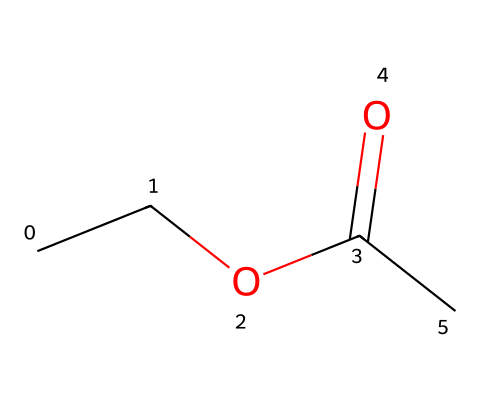What is the molecular formula of ethyl acetate? To determine the molecular formula, we need to count the number of each type of atom in the SMILES representation. The structure shows 4 carbon (C) atoms, 8 hydrogen (H) atoms, and 2 oxygen (O) atoms. Therefore, the molecular formula is C4H8O2.
Answer: C4H8O2 How many carbon atoms are present in ethyl acetate? By examining the SMILES, we can count 4 carbon atoms (C) in the structure. Each letter 'C' refers to a carbon atom.
Answer: 4 What type of bond connects the carbonyl carbon to the oxygen in ethyl acetate? In the structure, the carbonyl group (C=O) indicates a double bond between the carbon (C) and oxygen (O). The '=' symbol represents the double bond.
Answer: double bond What functional group characterizes ethyl acetate as an ester? Ethyl acetate contains a carbonyl (C=O) and an alkoxy group (–O–) attached to the carbon of the carbonyl, which is characteristic of esters. This specific arrangement qualifies it as an ester.
Answer: ester functional group Which part of ethyl acetate gives it its solvent properties? The ethyl group (–C2H5) contributes to the non-polar characteristics of ethyl acetate, while the carbonyl and alkoxy groups confer polarity, making it a good solvent for polar and non-polar substances. The balance of these groups facilitates its use as a solvent.
Answer: ethyl group What is the total number of oxygen atoms in the ethyl acetate molecule? The given SMILES indicates two 'O' occurrences in the structure, showing there are 2 oxygen atoms present in ethyl acetate.
Answer: 2 